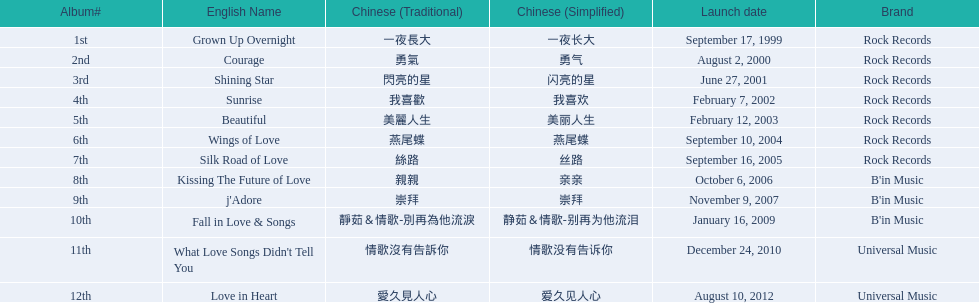Which english titles were released during even years? Courage, Sunrise, Silk Road of Love, Kissing The Future of Love, What Love Songs Didn't Tell You, Love in Heart. Out of the following, which one was released under b's in music? Kissing The Future of Love. 